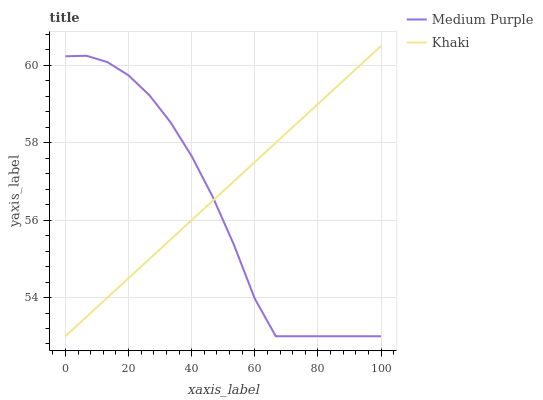Does Khaki have the minimum area under the curve?
Answer yes or no. No. Is Khaki the roughest?
Answer yes or no. No. 